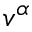Convert formula to latex. <formula><loc_0><loc_0><loc_500><loc_500>v ^ { \alpha }</formula> 